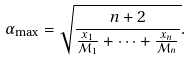<formula> <loc_0><loc_0><loc_500><loc_500>\alpha _ { \max } = \sqrt { \frac { n + 2 } { \frac { x _ { 1 } } { { \mathcal { M } } _ { 1 } } + \cdots + \frac { x _ { n } } { { \mathcal { M } } _ { n } } } } .</formula> 